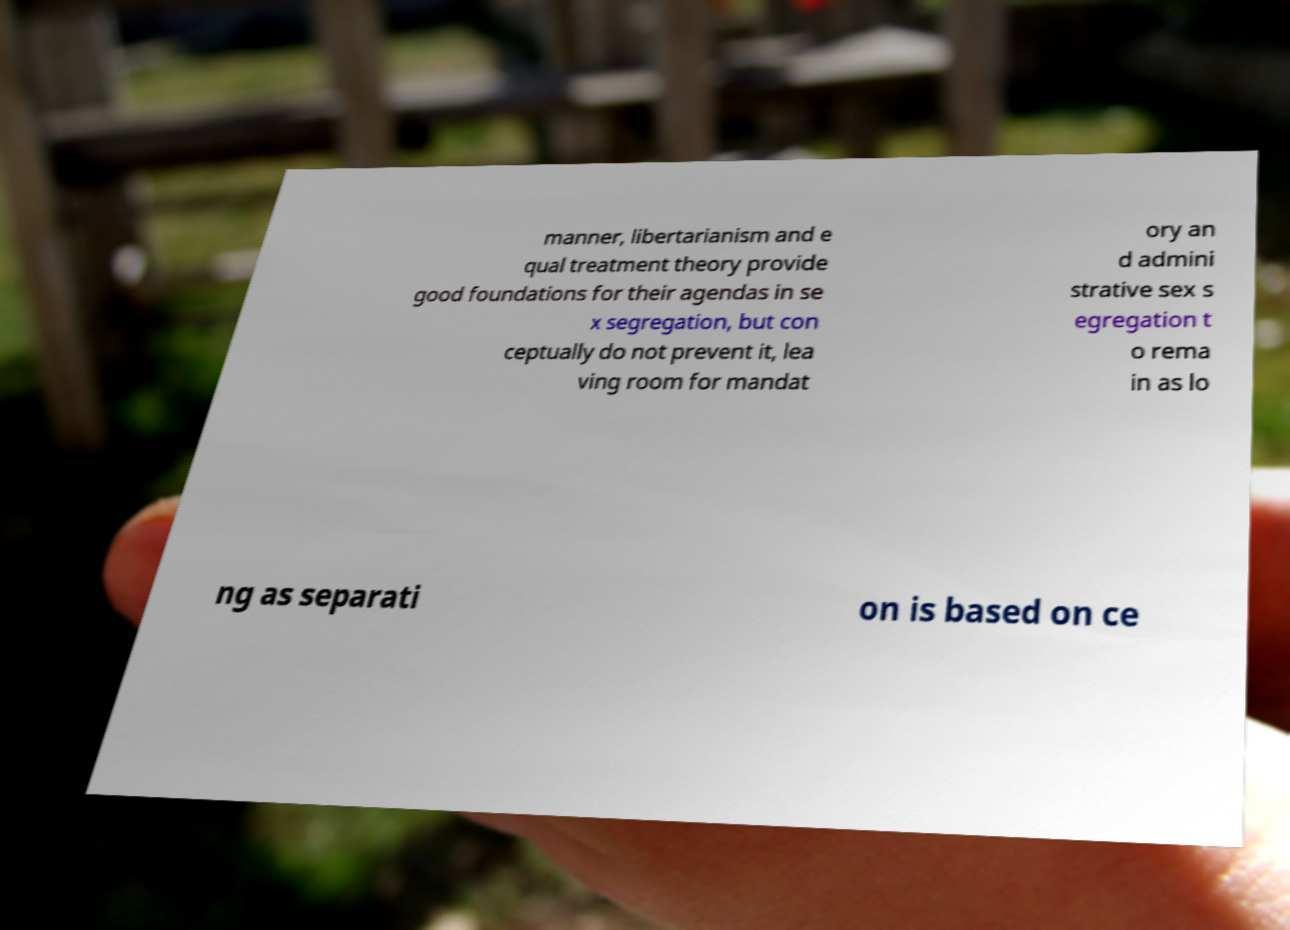What messages or text are displayed in this image? I need them in a readable, typed format. manner, libertarianism and e qual treatment theory provide good foundations for their agendas in se x segregation, but con ceptually do not prevent it, lea ving room for mandat ory an d admini strative sex s egregation t o rema in as lo ng as separati on is based on ce 